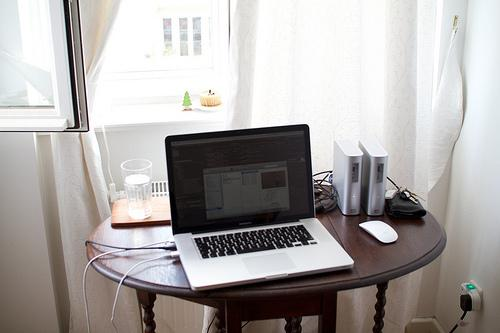Question: what is in the tall glass?
Choices:
A. Wine.
B. Beer.
C. Soda.
D. Water.
Answer with the letter. Answer: D Question: where is the picture taken?
Choices:
A. In a yard.
B. In a car.
C. In a mall.
D. In a room.
Answer with the letter. Answer: D 